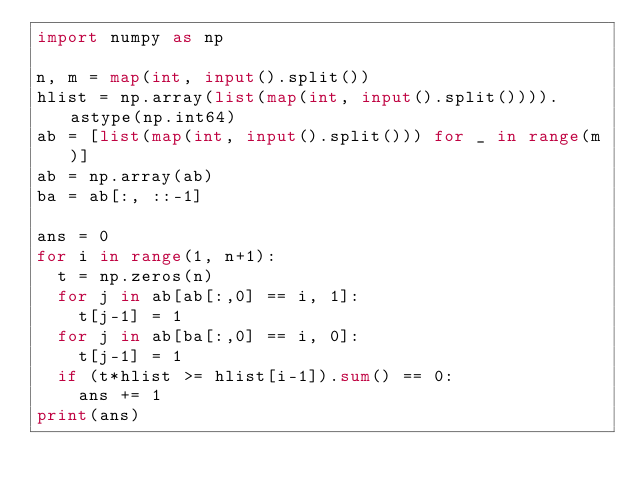<code> <loc_0><loc_0><loc_500><loc_500><_Python_>import numpy as np

n, m = map(int, input().split())
hlist = np.array(list(map(int, input().split()))).astype(np.int64)
ab = [list(map(int, input().split())) for _ in range(m)]
ab = np.array(ab)
ba = ab[:, ::-1]

ans = 0
for i in range(1, n+1):
  t = np.zeros(n)
  for j in ab[ab[:,0] == i, 1]:
    t[j-1] = 1
  for j in ab[ba[:,0] == i, 0]:
    t[j-1] = 1
  if (t*hlist >= hlist[i-1]).sum() == 0:
    ans += 1
print(ans)</code> 